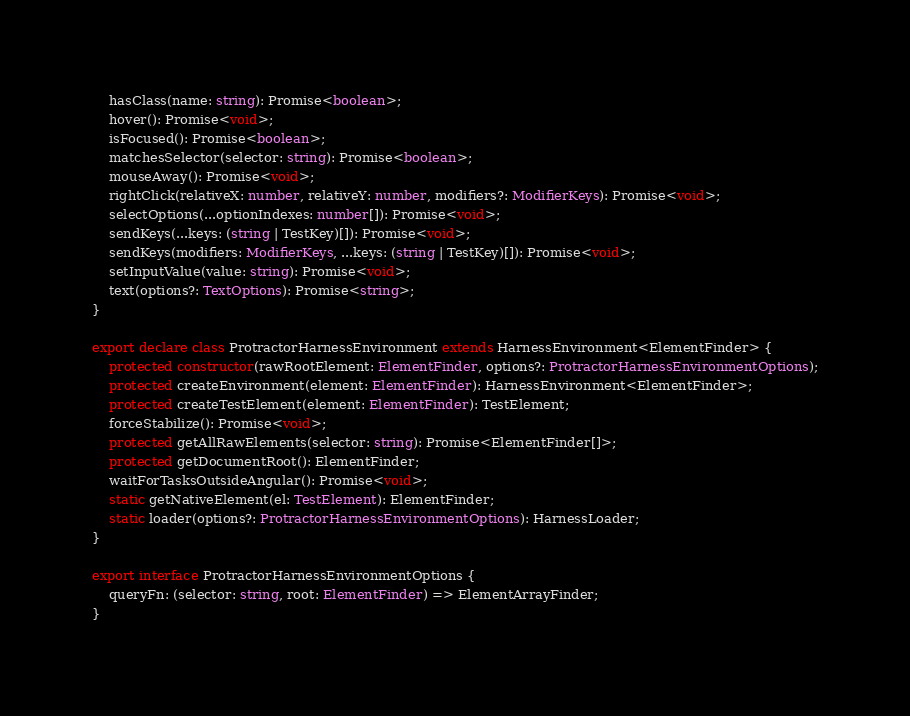Convert code to text. <code><loc_0><loc_0><loc_500><loc_500><_TypeScript_>    hasClass(name: string): Promise<boolean>;
    hover(): Promise<void>;
    isFocused(): Promise<boolean>;
    matchesSelector(selector: string): Promise<boolean>;
    mouseAway(): Promise<void>;
    rightClick(relativeX: number, relativeY: number, modifiers?: ModifierKeys): Promise<void>;
    selectOptions(...optionIndexes: number[]): Promise<void>;
    sendKeys(...keys: (string | TestKey)[]): Promise<void>;
    sendKeys(modifiers: ModifierKeys, ...keys: (string | TestKey)[]): Promise<void>;
    setInputValue(value: string): Promise<void>;
    text(options?: TextOptions): Promise<string>;
}

export declare class ProtractorHarnessEnvironment extends HarnessEnvironment<ElementFinder> {
    protected constructor(rawRootElement: ElementFinder, options?: ProtractorHarnessEnvironmentOptions);
    protected createEnvironment(element: ElementFinder): HarnessEnvironment<ElementFinder>;
    protected createTestElement(element: ElementFinder): TestElement;
    forceStabilize(): Promise<void>;
    protected getAllRawElements(selector: string): Promise<ElementFinder[]>;
    protected getDocumentRoot(): ElementFinder;
    waitForTasksOutsideAngular(): Promise<void>;
    static getNativeElement(el: TestElement): ElementFinder;
    static loader(options?: ProtractorHarnessEnvironmentOptions): HarnessLoader;
}

export interface ProtractorHarnessEnvironmentOptions {
    queryFn: (selector: string, root: ElementFinder) => ElementArrayFinder;
}
</code> 